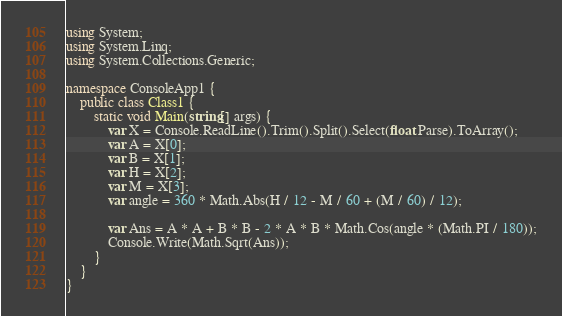Convert code to text. <code><loc_0><loc_0><loc_500><loc_500><_C#_>using System;
using System.Linq;
using System.Collections.Generic;

namespace ConsoleApp1 {
    public class Class1 {
        static void Main(string[] args) {
            var X = Console.ReadLine().Trim().Split().Select(float.Parse).ToArray();
            var A = X[0];
            var B = X[1];
            var H = X[2];
            var M = X[3];
            var angle = 360 * Math.Abs(H / 12 - M / 60 + (M / 60) / 12);

            var Ans = A * A + B * B - 2 * A * B * Math.Cos(angle * (Math.PI / 180));
            Console.Write(Math.Sqrt(Ans));
        }
    }
}</code> 